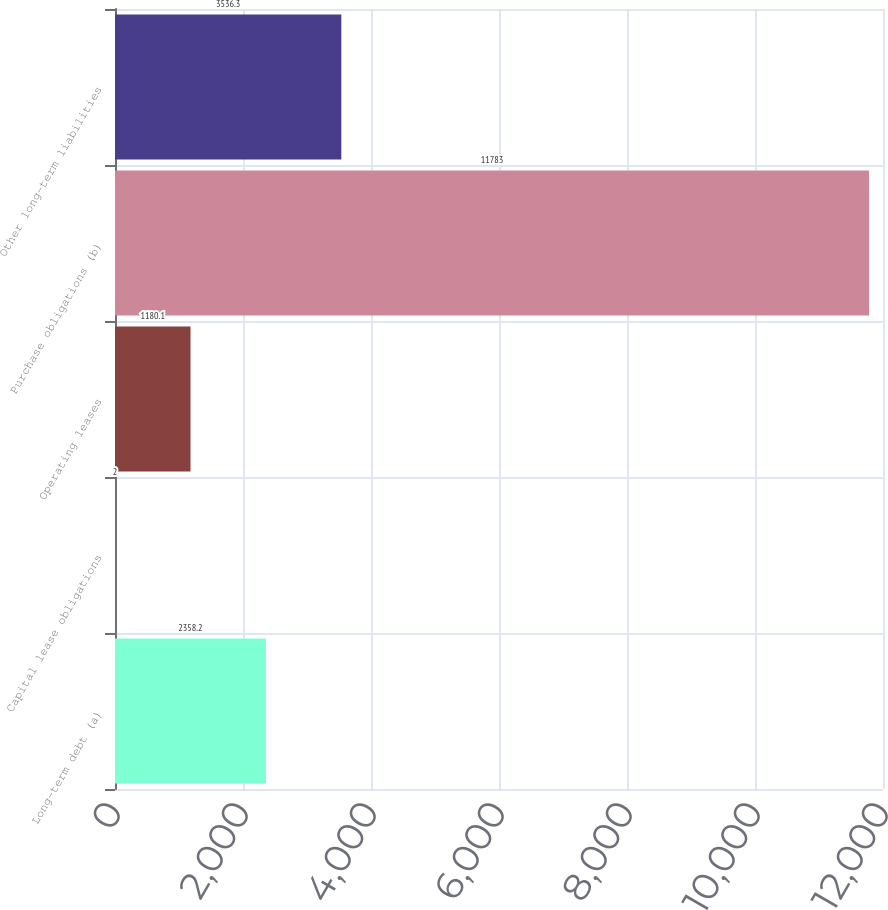Convert chart to OTSL. <chart><loc_0><loc_0><loc_500><loc_500><bar_chart><fcel>Long-term debt (a)<fcel>Capital lease obligations<fcel>Operating leases<fcel>Purchase obligations (b)<fcel>Other long-term liabilities<nl><fcel>2358.2<fcel>2<fcel>1180.1<fcel>11783<fcel>3536.3<nl></chart> 